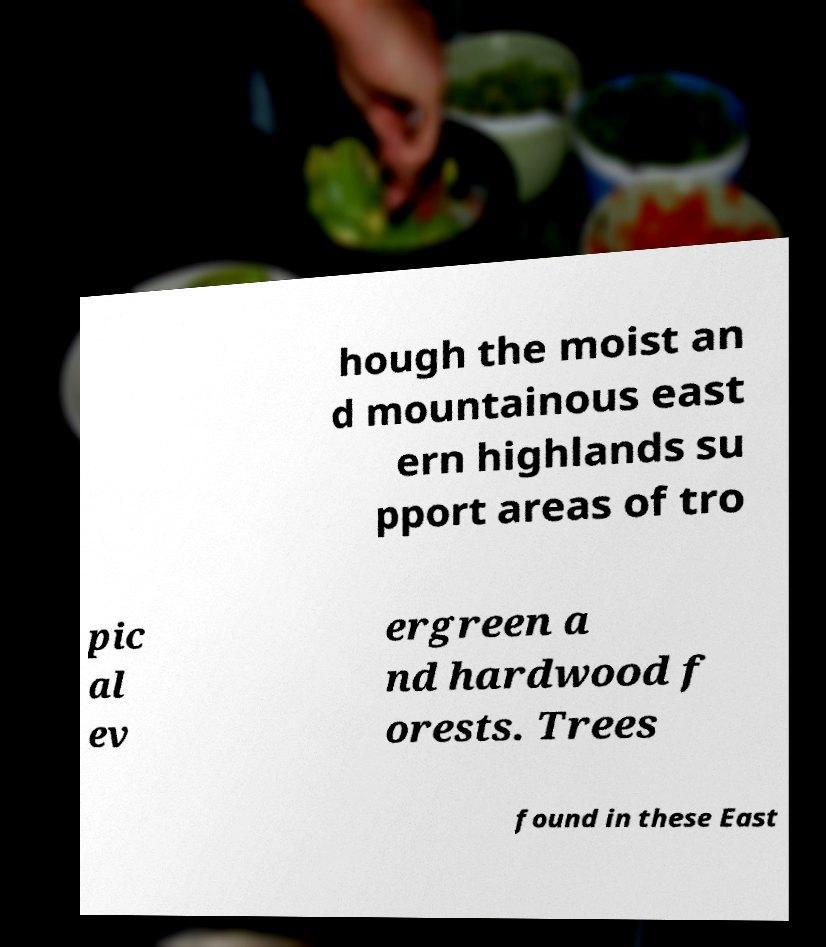What messages or text are displayed in this image? I need them in a readable, typed format. hough the moist an d mountainous east ern highlands su pport areas of tro pic al ev ergreen a nd hardwood f orests. Trees found in these East 